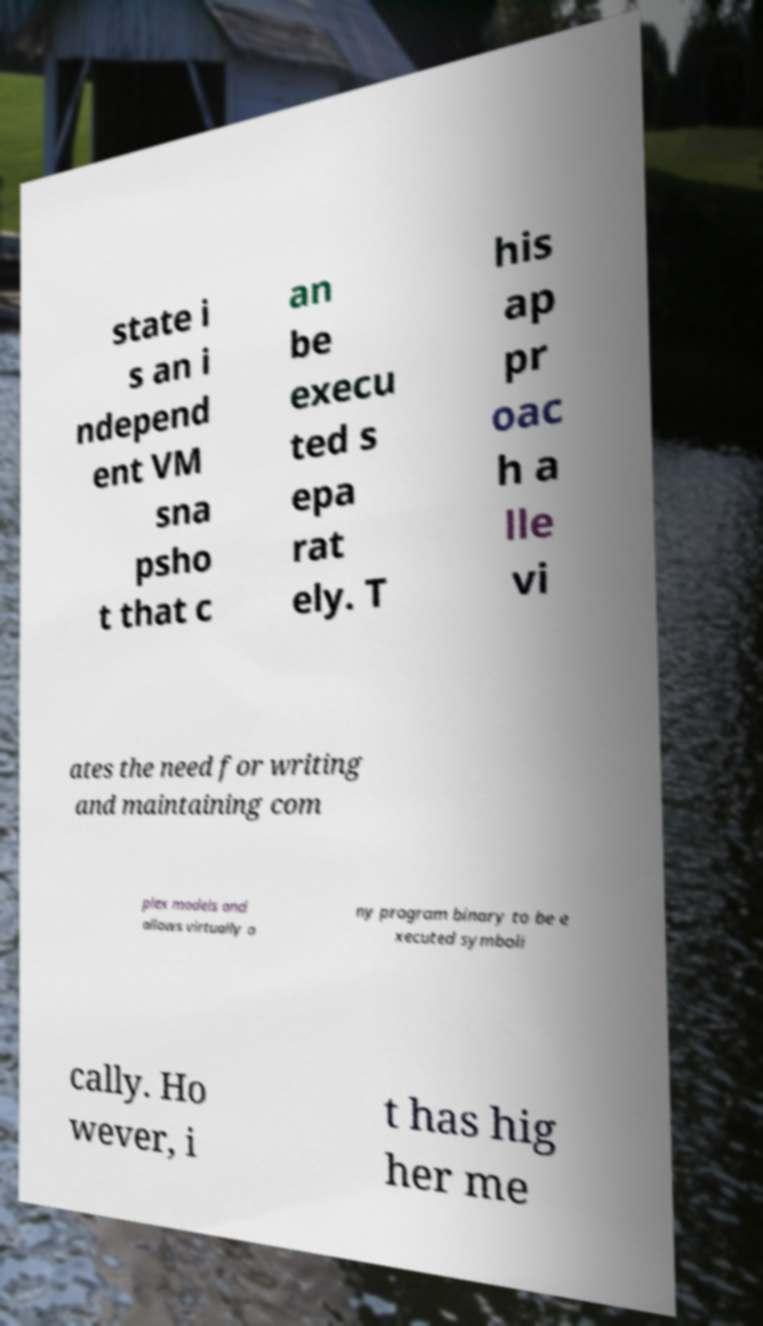Can you accurately transcribe the text from the provided image for me? state i s an i ndepend ent VM sna psho t that c an be execu ted s epa rat ely. T his ap pr oac h a lle vi ates the need for writing and maintaining com plex models and allows virtually a ny program binary to be e xecuted symboli cally. Ho wever, i t has hig her me 